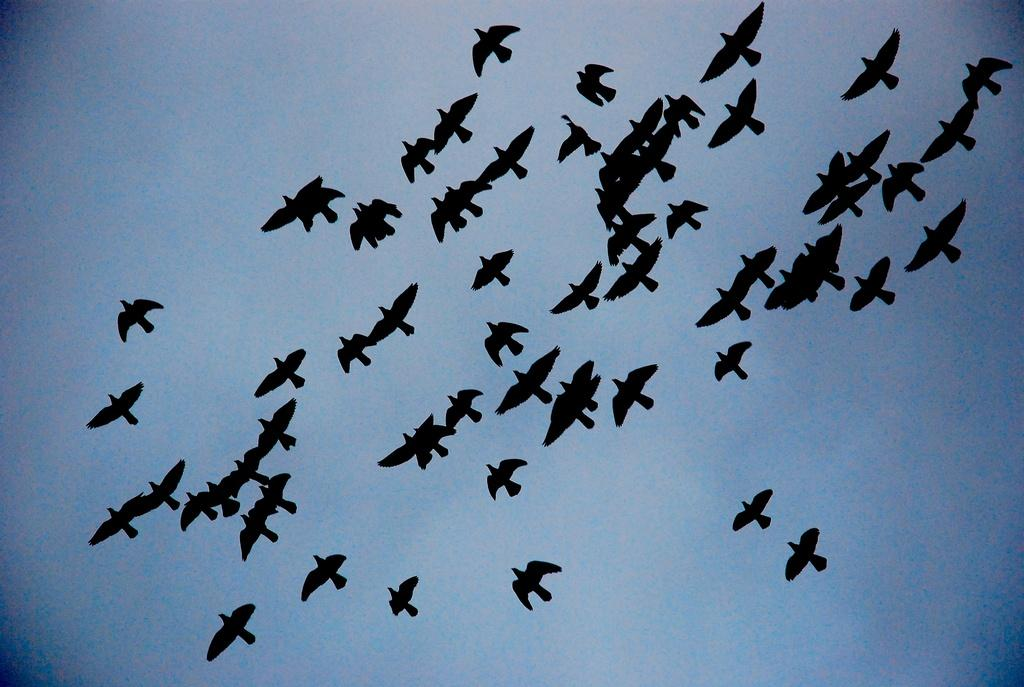What type of animals can be seen in the image? There are birds in the image. What is visible in the background of the image? There is a sky visible in the background of the image. What type of corn can be seen growing in the image? There is no corn present in the image; it features birds and a sky background. Can you see a kitten playing with the birds in the image? There is no kitten present in the image; it only features birds and a sky background. 